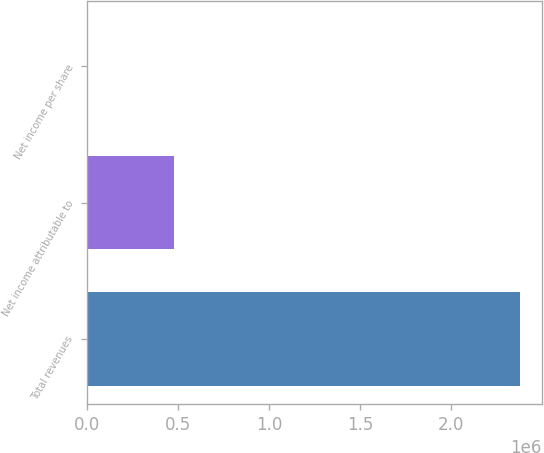<chart> <loc_0><loc_0><loc_500><loc_500><bar_chart><fcel>Total revenues<fcel>Net income attributable to<fcel>Net income per share<nl><fcel>2.3801e+06<fcel>476022<fcel>2.78<nl></chart> 